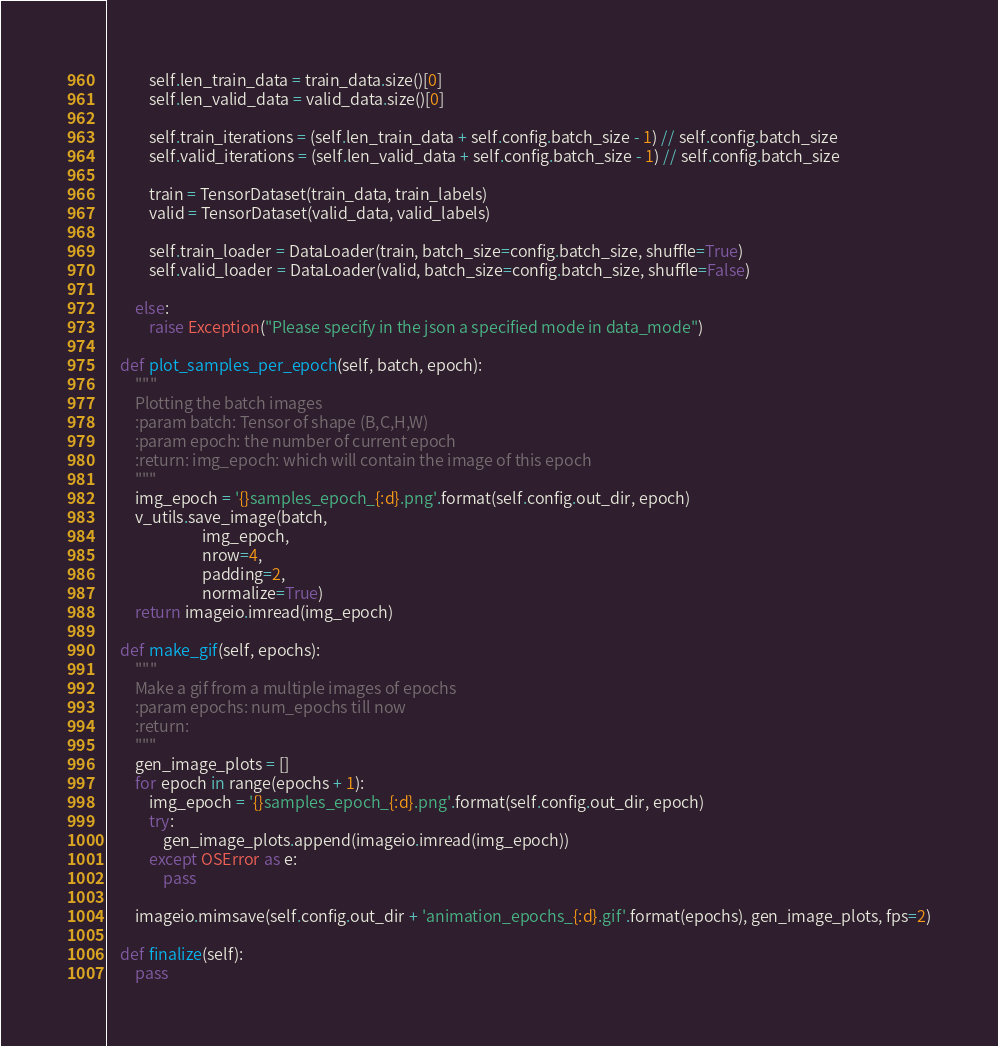<code> <loc_0><loc_0><loc_500><loc_500><_Python_>            self.len_train_data = train_data.size()[0]
            self.len_valid_data = valid_data.size()[0]

            self.train_iterations = (self.len_train_data + self.config.batch_size - 1) // self.config.batch_size
            self.valid_iterations = (self.len_valid_data + self.config.batch_size - 1) // self.config.batch_size

            train = TensorDataset(train_data, train_labels)
            valid = TensorDataset(valid_data, valid_labels)

            self.train_loader = DataLoader(train, batch_size=config.batch_size, shuffle=True)
            self.valid_loader = DataLoader(valid, batch_size=config.batch_size, shuffle=False)

        else:
            raise Exception("Please specify in the json a specified mode in data_mode")

    def plot_samples_per_epoch(self, batch, epoch):
        """
        Plotting the batch images
        :param batch: Tensor of shape (B,C,H,W)
        :param epoch: the number of current epoch
        :return: img_epoch: which will contain the image of this epoch
        """
        img_epoch = '{}samples_epoch_{:d}.png'.format(self.config.out_dir, epoch)
        v_utils.save_image(batch,
                           img_epoch,
                           nrow=4,
                           padding=2,
                           normalize=True)
        return imageio.imread(img_epoch)

    def make_gif(self, epochs):
        """
        Make a gif from a multiple images of epochs
        :param epochs: num_epochs till now
        :return:
        """
        gen_image_plots = []
        for epoch in range(epochs + 1):
            img_epoch = '{}samples_epoch_{:d}.png'.format(self.config.out_dir, epoch)
            try:
                gen_image_plots.append(imageio.imread(img_epoch))
            except OSError as e:
                pass

        imageio.mimsave(self.config.out_dir + 'animation_epochs_{:d}.gif'.format(epochs), gen_image_plots, fps=2)

    def finalize(self):
        pass
</code> 